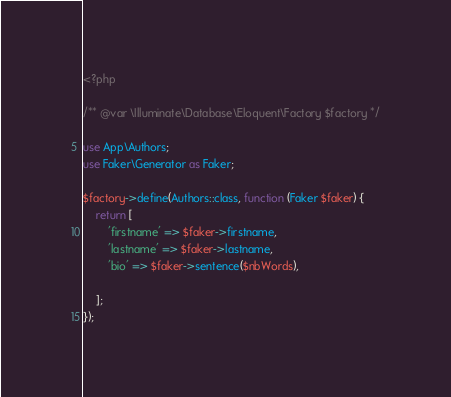Convert code to text. <code><loc_0><loc_0><loc_500><loc_500><_PHP_><?php

/** @var \Illuminate\Database\Eloquent\Factory $factory */

use App\Authors;
use Faker\Generator as Faker;

$factory->define(Authors::class, function (Faker $faker) {
    return [
        'firstname' => $faker->firstname,
        'lastname' => $faker->lastname,
        'bio' => $faker->sentence($nbWords),
    
    ];
});
</code> 